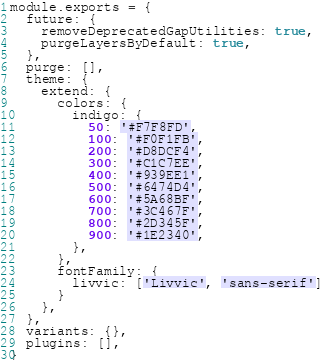Convert code to text. <code><loc_0><loc_0><loc_500><loc_500><_JavaScript_>module.exports = {
  future: {
    removeDeprecatedGapUtilities: true,
    purgeLayersByDefault: true,
  },
  purge: [],
  theme: {
    extend: {
      colors: {
        indigo: {
          50: '#F7F8FD',
          100: '#F0F1FB',
          200: '#D8DCF4',
          300: '#C1C7EE',
          400: '#939EE1',
          500: '#6474D4',
          600: '#5A68BF',
          700: '#3C467F',
          800: '#2D345F',
          900: '#1E2340',
        },
      },
      fontFamily: {
        livvic: ['Livvic', 'sans-serif']
      }
    },
  },
  variants: {},
  plugins: [],
}
</code> 